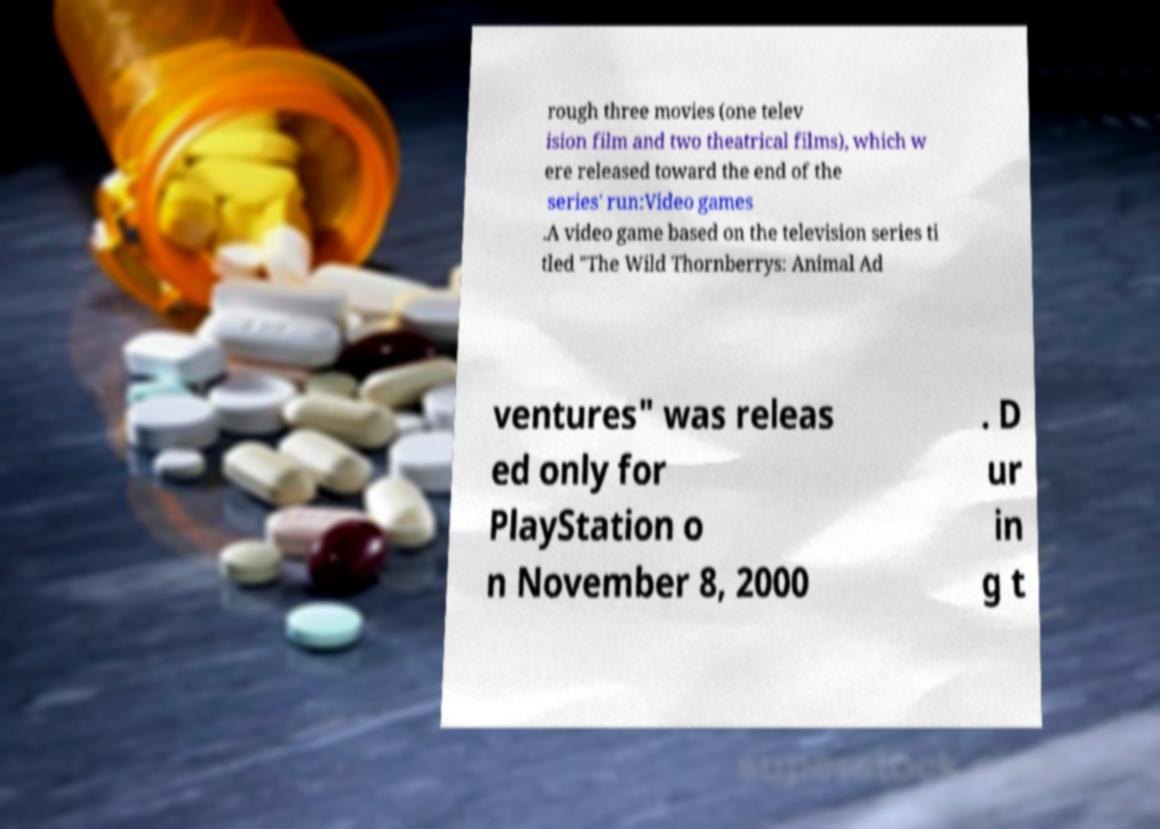Can you accurately transcribe the text from the provided image for me? rough three movies (one telev ision film and two theatrical films), which w ere released toward the end of the series' run:Video games .A video game based on the television series ti tled "The Wild Thornberrys: Animal Ad ventures" was releas ed only for PlayStation o n November 8, 2000 . D ur in g t 